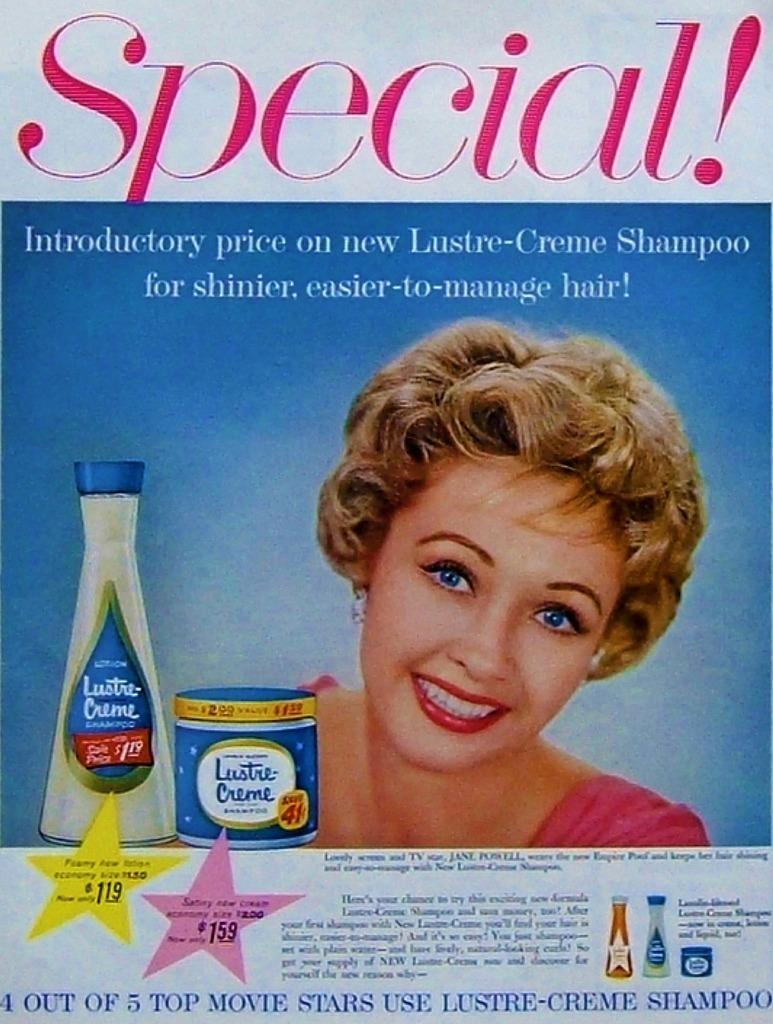Provide a one-sentence caption for the provided image. An old ad that has a lady on it smiling and says Special that has two bottles of Lustre Cream on it. 